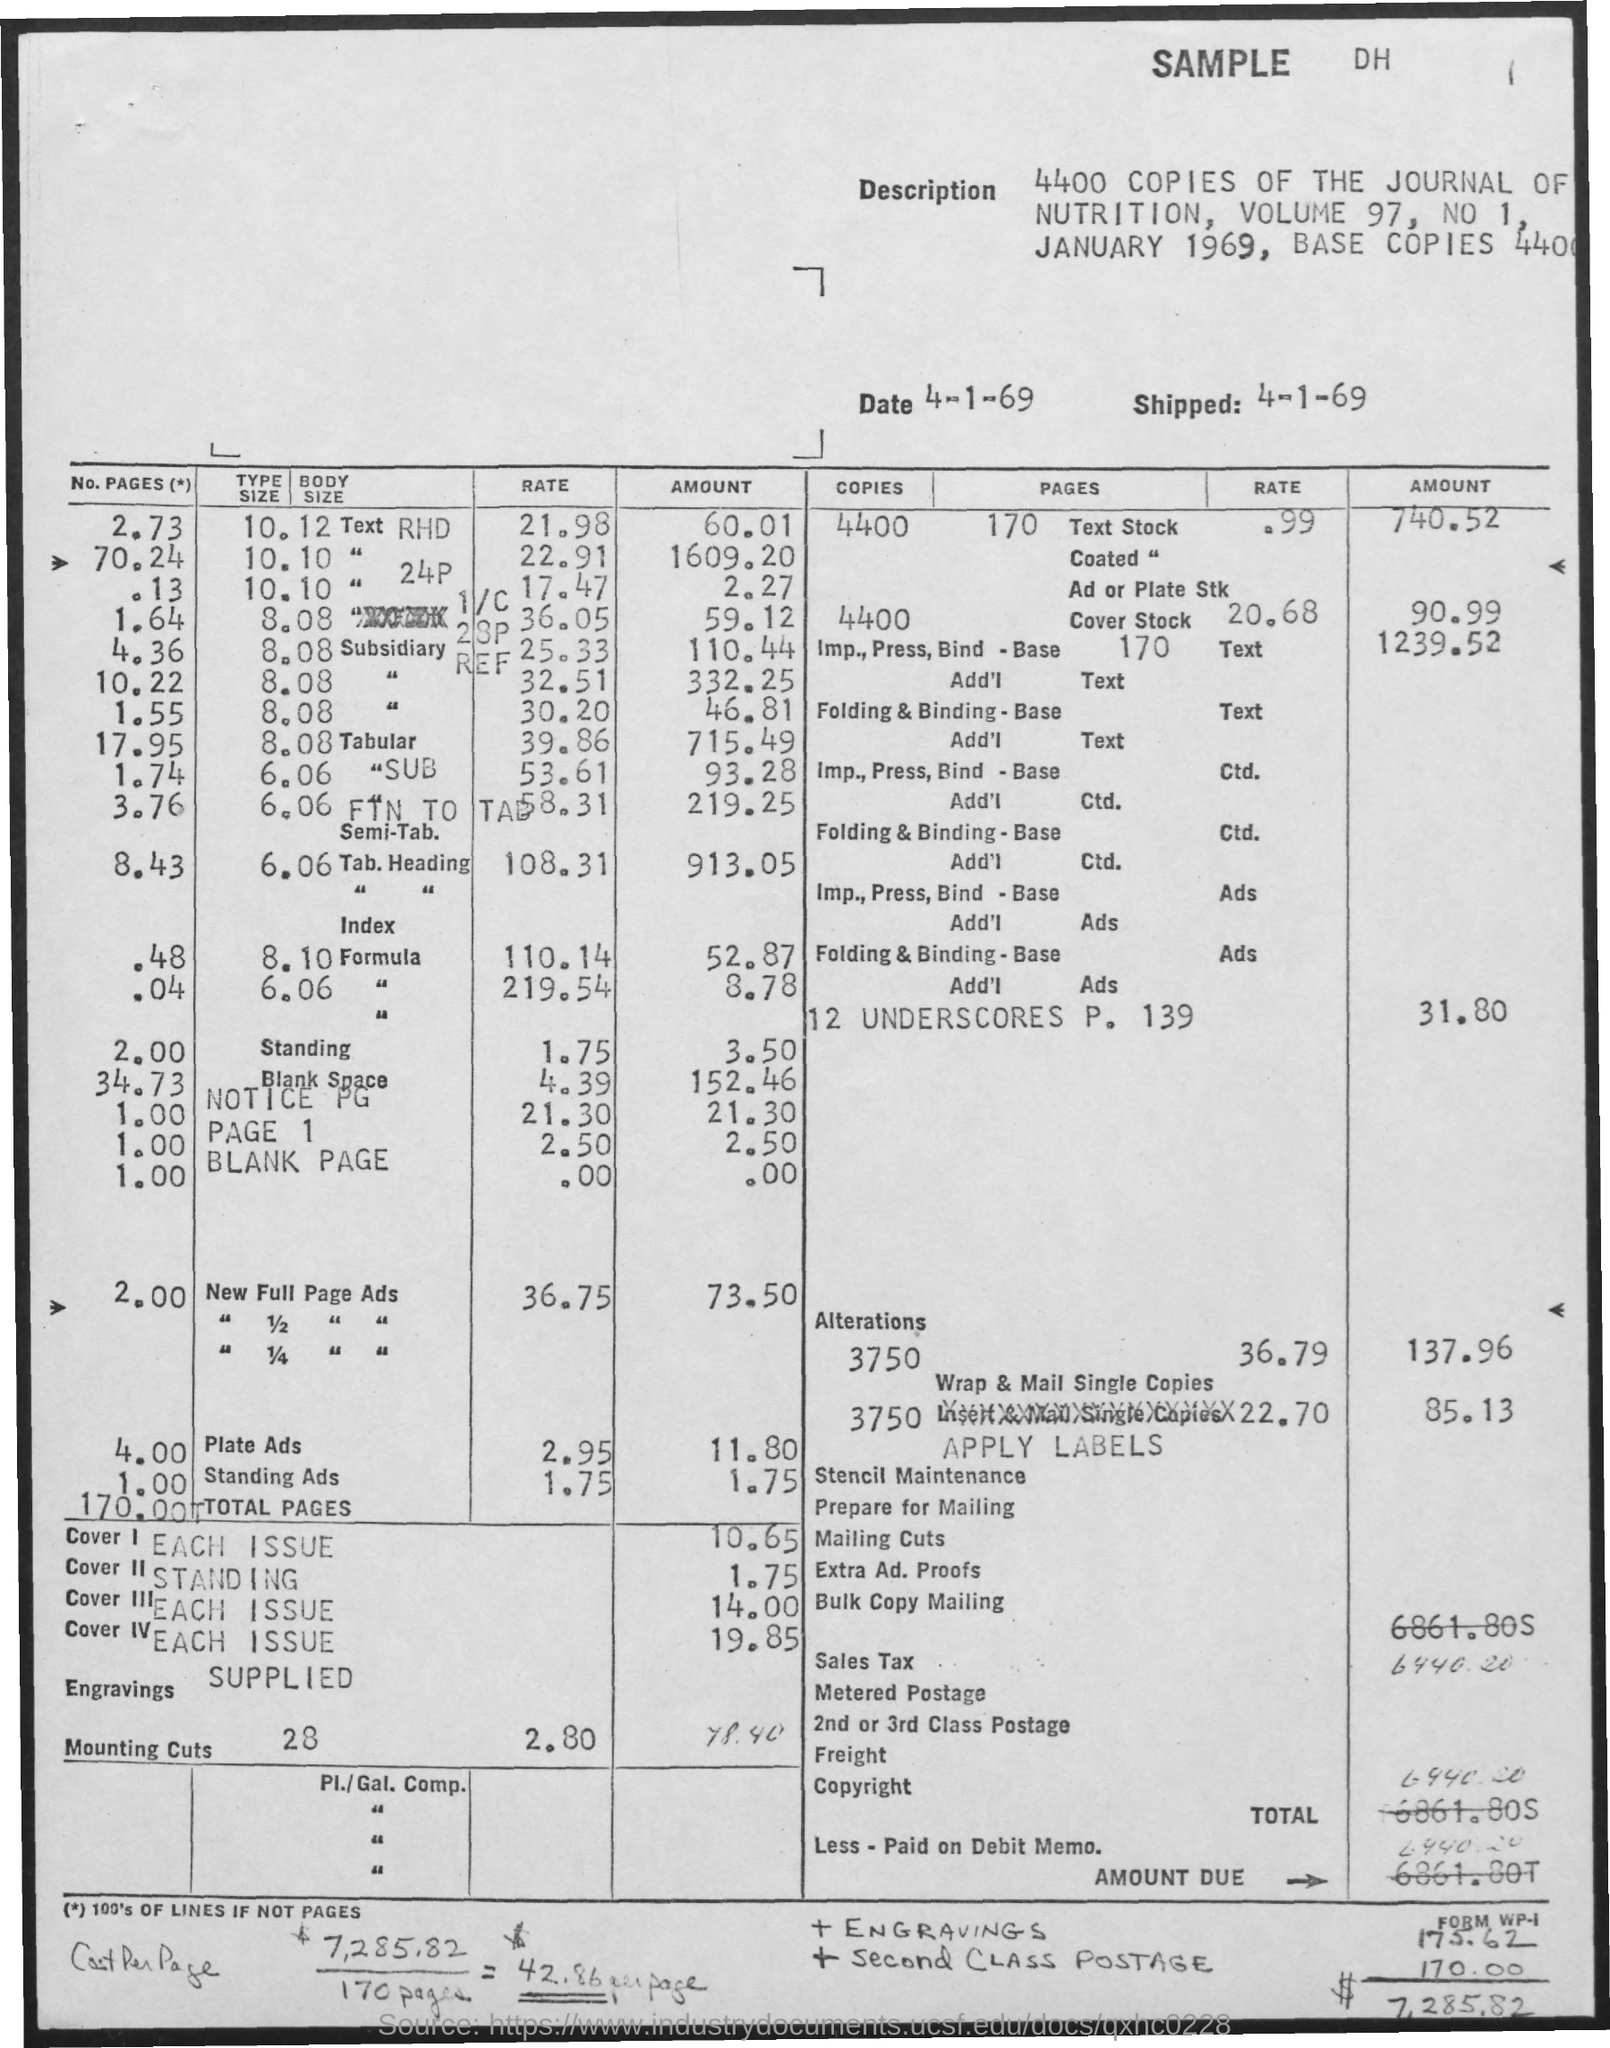What is the date of shipping?
Give a very brief answer. 4-1-69. How many numbers of copies of the journal of nutrition?
Make the answer very short. 4400. What is the volume number?
Your response must be concise. 97. 